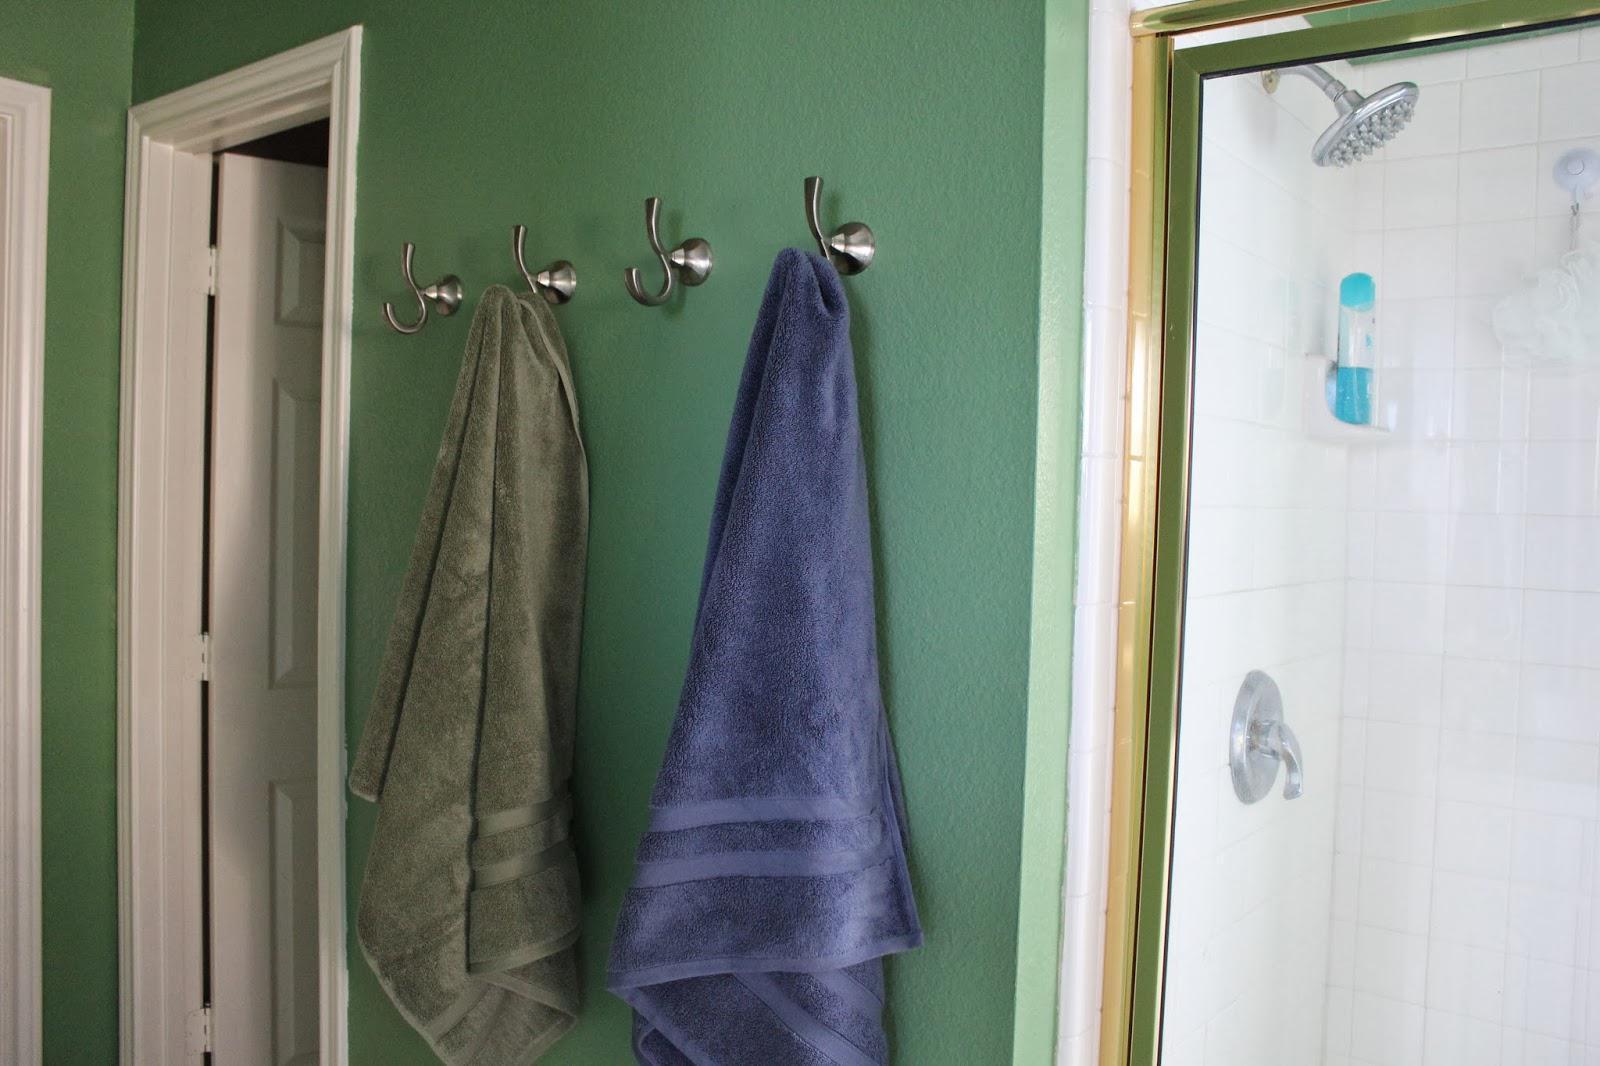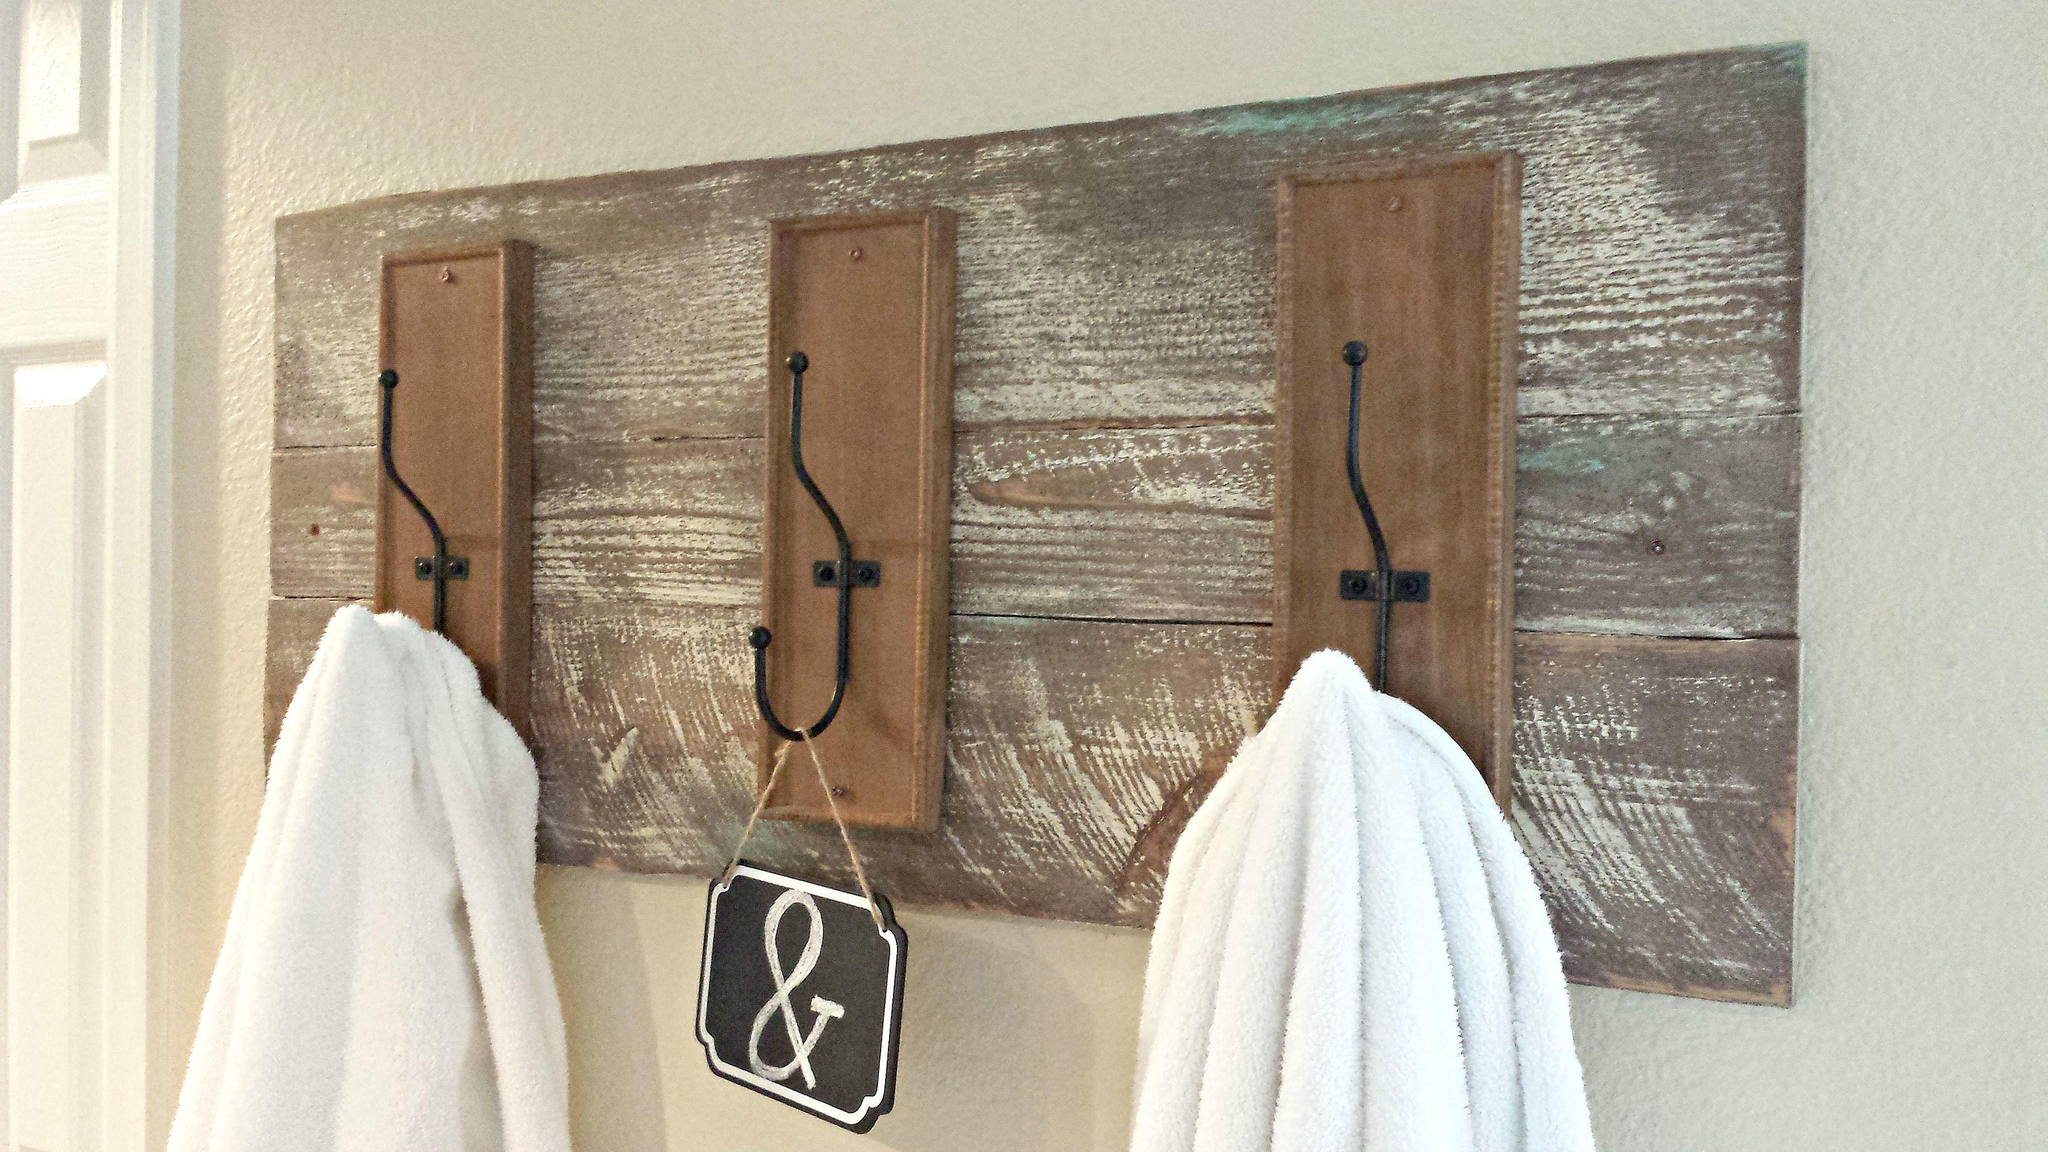The first image is the image on the left, the second image is the image on the right. For the images displayed, is the sentence "There are two hanging towels in the left image." factually correct? Answer yes or no. Yes. The first image is the image on the left, the second image is the image on the right. Evaluate the accuracy of this statement regarding the images: "In one of the images, the towels are hung on something mounted to a wooden board along the wall.". Is it true? Answer yes or no. Yes. 